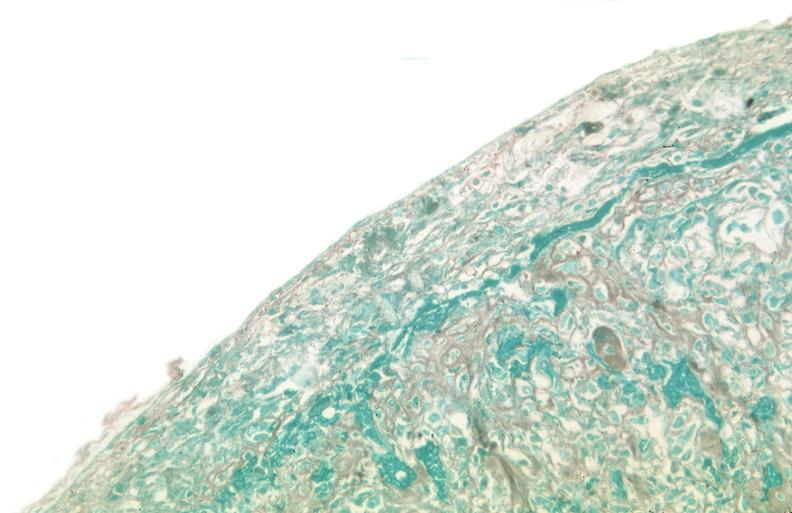s respiratory present?
Answer the question using a single word or phrase. Yes 